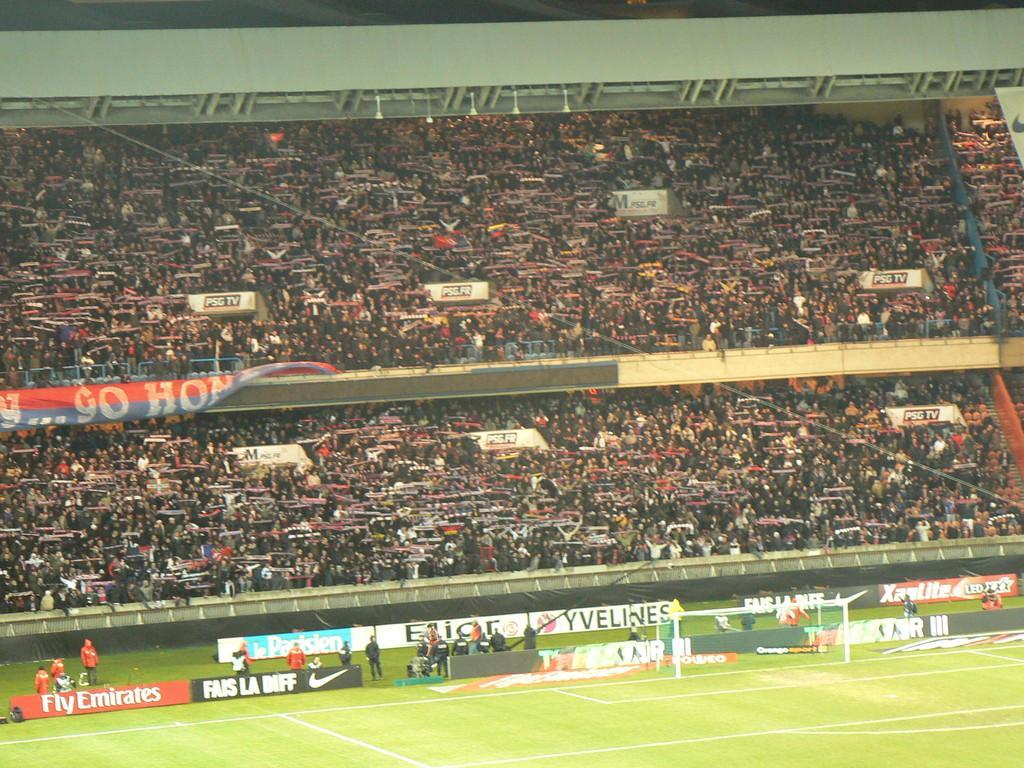Please provide a concise description of this image. In this picture we can see the ground, football net, posters and some people are standing on the grass and in the background we can see a group of people, banner and some objects. 